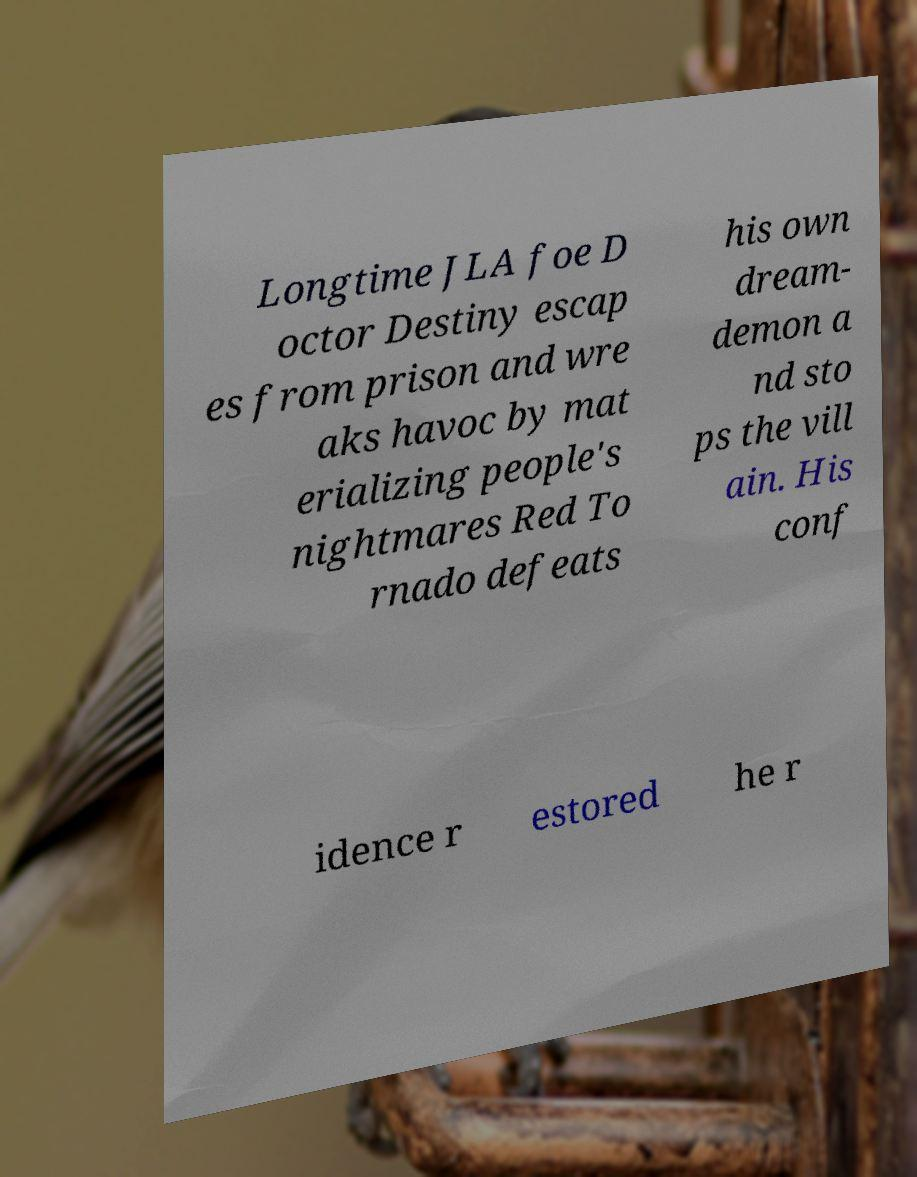Could you assist in decoding the text presented in this image and type it out clearly? Longtime JLA foe D octor Destiny escap es from prison and wre aks havoc by mat erializing people's nightmares Red To rnado defeats his own dream- demon a nd sto ps the vill ain. His conf idence r estored he r 